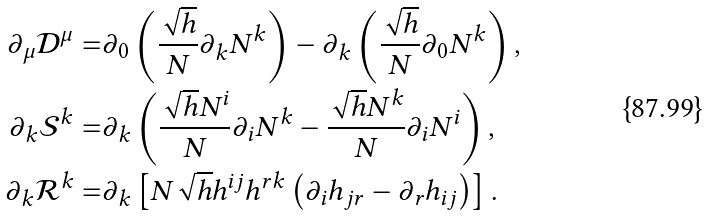Convert formula to latex. <formula><loc_0><loc_0><loc_500><loc_500>\partial _ { \mu } \mathcal { D } ^ { \mu } = & \partial _ { 0 } \left ( \frac { \sqrt { h } } { N } \partial _ { k } N ^ { k } \right ) - \partial _ { k } \left ( \frac { \sqrt { h } } { N } \partial _ { 0 } N ^ { k } \right ) , \\ \partial _ { k } \mathcal { S } ^ { k } = & \partial _ { k } \left ( \frac { \sqrt { h } N ^ { i } } { N } \partial _ { i } N ^ { k } - \frac { \sqrt { h } N ^ { k } } { N } \partial _ { i } N ^ { i } \right ) , \\ \partial _ { k } \mathcal { R } ^ { k } = & \partial _ { k } \left [ N \sqrt { h } h ^ { i j } h ^ { r k } \left ( \partial _ { i } h _ { j r } - \partial _ { r } h _ { i j } \right ) \right ] .</formula> 